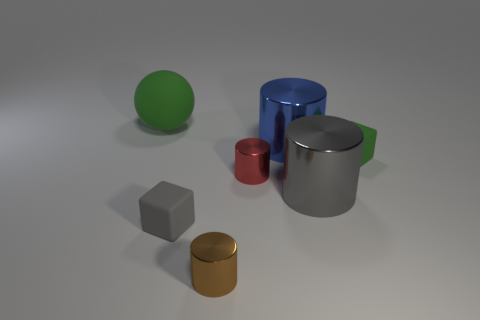Comparing the cylinders in the image, what can you tell me about their relative sizes and positions? In the image, there are three cylinders of different sizes and colors. The largest one is blue and is centrally positioned while the smaller one is red, located to the right of the blue one, and the third cylinder is silver and of medium size, found to the left of the blue one. A small gold cylinder is also present, off to the bottom left corner, not in line with the other cylinders in terms of height or size. 